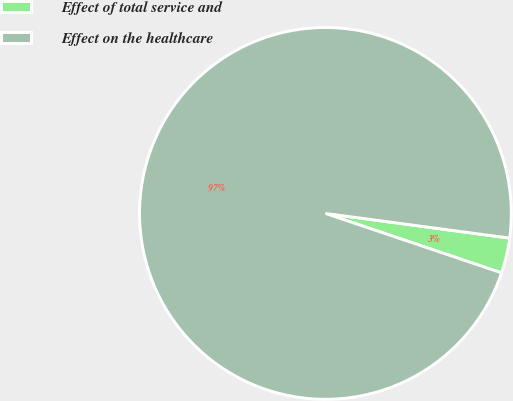Convert chart. <chart><loc_0><loc_0><loc_500><loc_500><pie_chart><fcel>Effect of total service and<fcel>Effect on the healthcare<nl><fcel>3.06%<fcel>96.94%<nl></chart> 